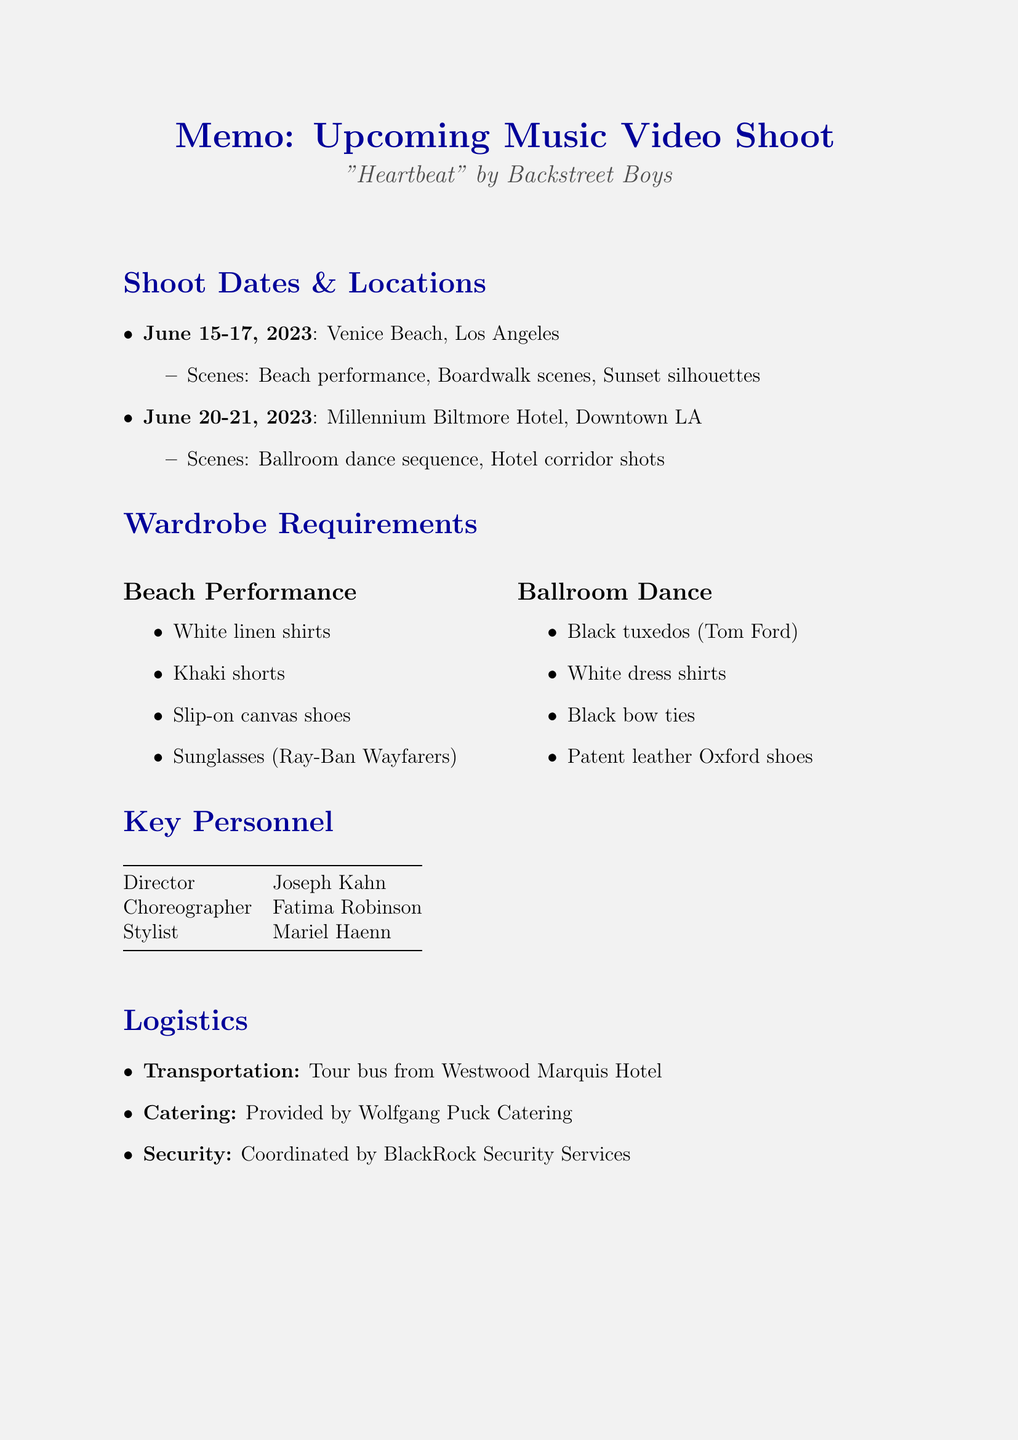What are the shoot dates? The shoot dates include June 15-17, 2023 and June 20-21, 2023.
Answer: June 15-17, 2023; June 20-21, 2023 Where is the beach performance scene being shot? The location for the beach performance scene is mentioned as Venice Beach, Los Angeles.
Answer: Venice Beach, Los Angeles What is the total budget for the music video shoot? The total budget is specified in the document as $1.5 million.
Answer: $1.5 million What special requirement is mentioned for the beach scenes? One of the special requirements for the beach scenes is waterproof makeup.
Answer: Waterproof makeup Who is the choreographer for the music video? The document lists Fatima Robinson as the choreographer.
Answer: Fatima Robinson What types of outfits are required for the ballroom dance sequence? The document specifies black tuxedos, white dress shirts, black bow ties, and patent leather Oxford shoes for this scene.
Answer: Black tuxedos, white dress shirts, black bow ties, patent leather Oxford shoes When is the rough cut due? The due date for the rough cut is directly stated in the document.
Answer: July 5, 2023 What type of transportation is arranged for the crew? The document notes that a tour bus is the arranged transportation for the crew.
Answer: Tour bus 